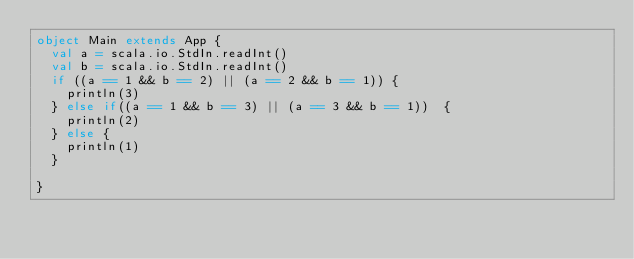<code> <loc_0><loc_0><loc_500><loc_500><_Scala_>object Main extends App {
  val a = scala.io.StdIn.readInt()
  val b = scala.io.StdIn.readInt()
  if ((a == 1 && b == 2) || (a == 2 && b == 1)) {
    println(3)
  } else if((a == 1 && b == 3) || (a == 3 && b == 1))  {
    println(2)
  } else {
    println(1)
  }

}</code> 